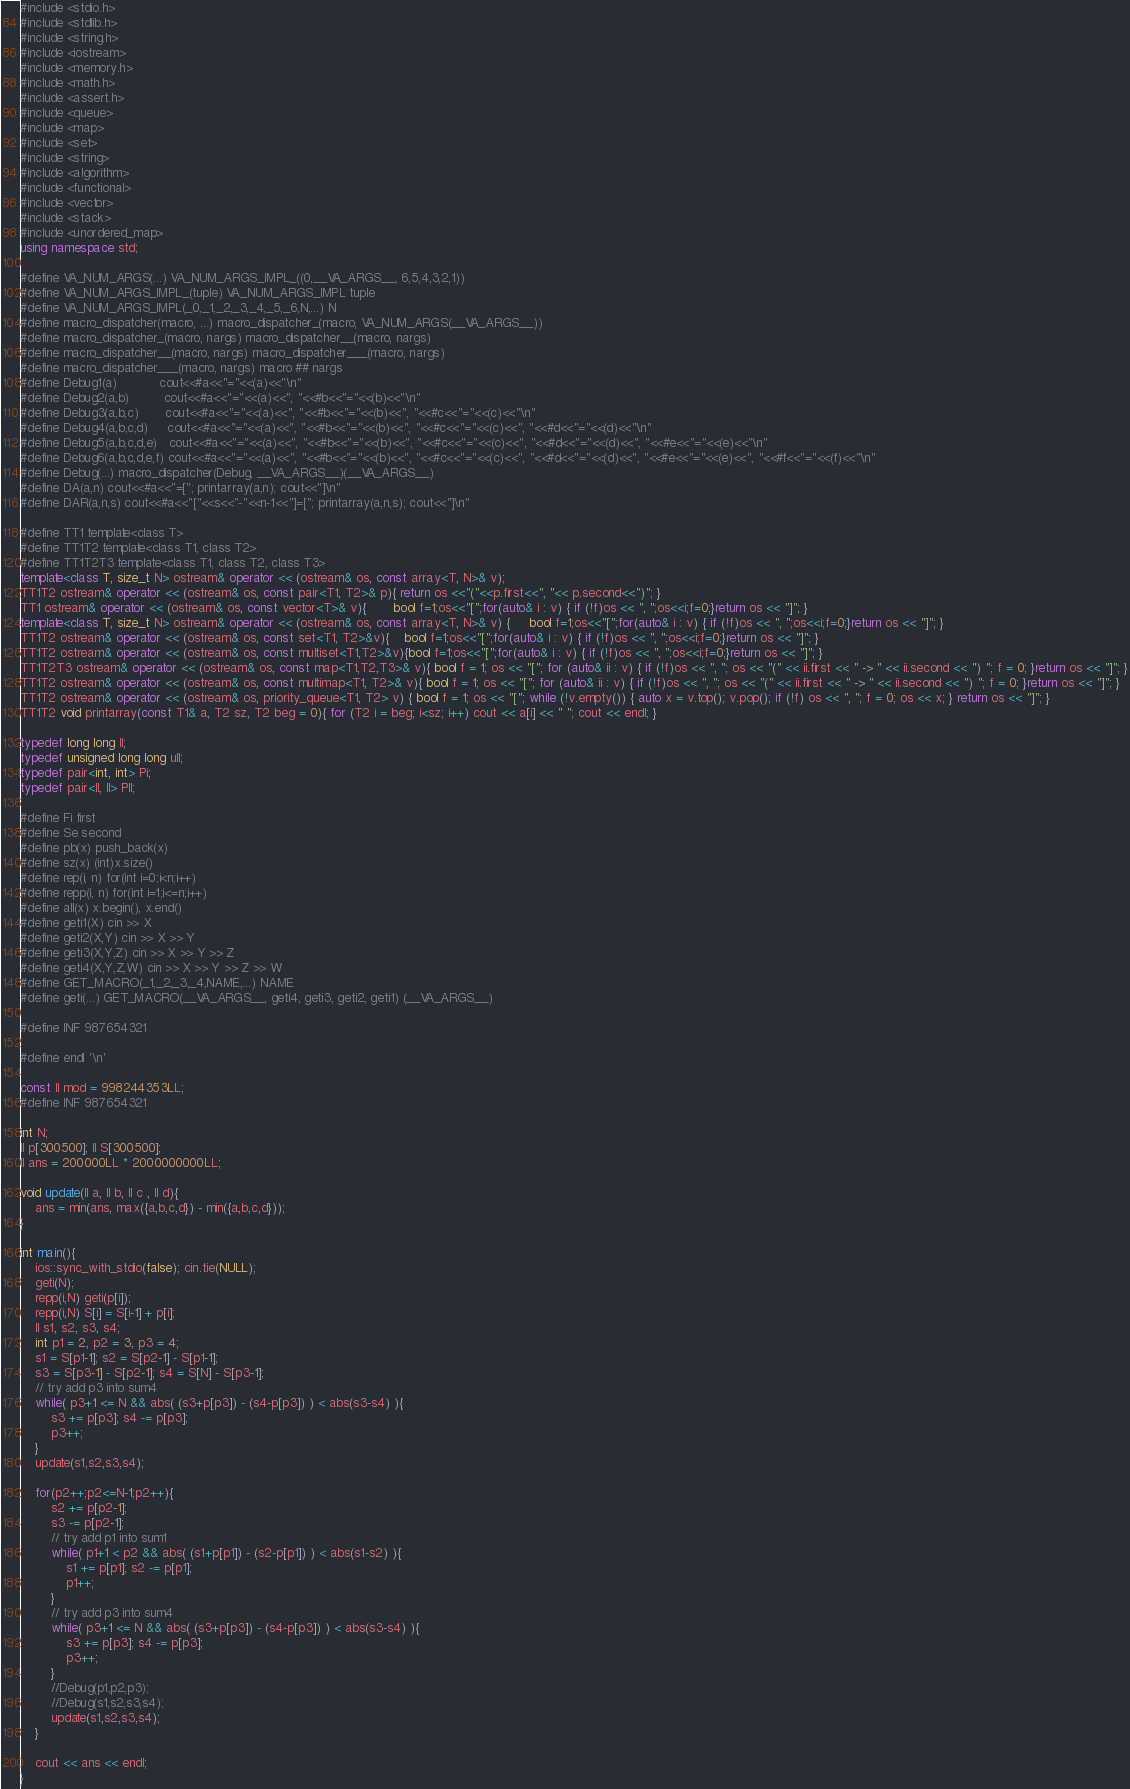<code> <loc_0><loc_0><loc_500><loc_500><_C++_>#include <stdio.h>
#include <stdlib.h>
#include <string.h>
#include <iostream>
#include <memory.h>
#include <math.h>
#include <assert.h>
#include <queue>
#include <map>
#include <set>
#include <string>
#include <algorithm>
#include <functional>
#include <vector>
#include <stack>
#include <unordered_map>
using namespace std;

#define VA_NUM_ARGS(...) VA_NUM_ARGS_IMPL_((0,__VA_ARGS__, 6,5,4,3,2,1))
#define VA_NUM_ARGS_IMPL_(tuple) VA_NUM_ARGS_IMPL tuple
#define VA_NUM_ARGS_IMPL(_0,_1,_2,_3,_4,_5,_6,N,...) N
#define macro_dispatcher(macro, ...) macro_dispatcher_(macro, VA_NUM_ARGS(__VA_ARGS__))
#define macro_dispatcher_(macro, nargs) macro_dispatcher__(macro, nargs)
#define macro_dispatcher__(macro, nargs) macro_dispatcher___(macro, nargs)
#define macro_dispatcher___(macro, nargs) macro ## nargs
#define Debug1(a)           cout<<#a<<"="<<(a)<<"\n"
#define Debug2(a,b)         cout<<#a<<"="<<(a)<<", "<<#b<<"="<<(b)<<"\n"
#define Debug3(a,b,c)       cout<<#a<<"="<<(a)<<", "<<#b<<"="<<(b)<<", "<<#c<<"="<<(c)<<"\n"
#define Debug4(a,b,c,d)     cout<<#a<<"="<<(a)<<", "<<#b<<"="<<(b)<<", "<<#c<<"="<<(c)<<", "<<#d<<"="<<(d)<<"\n"
#define Debug5(a,b,c,d,e)   cout<<#a<<"="<<(a)<<", "<<#b<<"="<<(b)<<", "<<#c<<"="<<(c)<<", "<<#d<<"="<<(d)<<", "<<#e<<"="<<(e)<<"\n"
#define Debug6(a,b,c,d,e,f) cout<<#a<<"="<<(a)<<", "<<#b<<"="<<(b)<<", "<<#c<<"="<<(c)<<", "<<#d<<"="<<(d)<<", "<<#e<<"="<<(e)<<", "<<#f<<"="<<(f)<<"\n"
#define Debug(...) macro_dispatcher(Debug, __VA_ARGS__)(__VA_ARGS__)
#define DA(a,n) cout<<#a<<"=["; printarray(a,n); cout<<"]\n"
#define DAR(a,n,s) cout<<#a<<"["<<s<<"-"<<n-1<<"]=["; printarray(a,n,s); cout<<"]\n"

#define TT1 template<class T>
#define TT1T2 template<class T1, class T2>
#define TT1T2T3 template<class T1, class T2, class T3>
template<class T, size_t N> ostream& operator << (ostream& os, const array<T, N>& v);
TT1T2 ostream& operator << (ostream& os, const pair<T1, T2>& p){ return os <<"("<<p.first<<", "<< p.second<<")"; }
TT1 ostream& operator << (ostream& os, const vector<T>& v){       bool f=1;os<<"[";for(auto& i : v) { if (!f)os << ", ";os<<i;f=0;}return os << "]"; }
template<class T, size_t N> ostream& operator << (ostream& os, const array<T, N>& v) {     bool f=1;os<<"[";for(auto& i : v) { if (!f)os << ", ";os<<i;f=0;}return os << "]"; }
TT1T2 ostream& operator << (ostream& os, const set<T1, T2>&v){    bool f=1;os<<"[";for(auto& i : v) { if (!f)os << ", ";os<<i;f=0;}return os << "]"; }
TT1T2 ostream& operator << (ostream& os, const multiset<T1,T2>&v){bool f=1;os<<"[";for(auto& i : v) { if (!f)os << ", ";os<<i;f=0;}return os << "]"; }
TT1T2T3 ostream& operator << (ostream& os, const map<T1,T2,T3>& v){ bool f = 1; os << "["; for (auto& ii : v) { if (!f)os << ", "; os << "(" << ii.first << " -> " << ii.second << ") "; f = 0; }return os << "]"; }
TT1T2 ostream& operator << (ostream& os, const multimap<T1, T2>& v){ bool f = 1; os << "["; for (auto& ii : v) { if (!f)os << ", "; os << "(" << ii.first << " -> " << ii.second << ") "; f = 0; }return os << "]"; }
TT1T2 ostream& operator << (ostream& os, priority_queue<T1, T2> v) { bool f = 1; os << "["; while (!v.empty()) { auto x = v.top(); v.pop(); if (!f) os << ", "; f = 0; os << x; } return os << "]"; }
TT1T2 void printarray(const T1& a, T2 sz, T2 beg = 0){ for (T2 i = beg; i<sz; i++) cout << a[i] << " "; cout << endl; }

typedef long long ll;
typedef unsigned long long ull;
typedef pair<int, int> Pi;
typedef pair<ll, ll> Pll;

#define Fi first
#define Se second
#define pb(x) push_back(x)
#define sz(x) (int)x.size()
#define rep(i, n) for(int i=0;i<n;i++)
#define repp(i, n) for(int i=1;i<=n;i++)
#define all(x) x.begin(), x.end()
#define geti1(X) cin >> X
#define geti2(X,Y) cin >> X >> Y
#define geti3(X,Y,Z) cin >> X >> Y >> Z
#define geti4(X,Y,Z,W) cin >> X >> Y >> Z >> W
#define GET_MACRO(_1,_2,_3,_4,NAME,...) NAME
#define geti(...) GET_MACRO(__VA_ARGS__, geti4, geti3, geti2, geti1) (__VA_ARGS__)

#define INF 987654321

#define endl '\n'

const ll mod = 998244353LL;
#define INF 987654321

int N;
ll p[300500]; ll S[300500];
ll ans = 200000LL * 2000000000LL;

void update(ll a, ll b, ll c , ll d){
	ans = min(ans, max({a,b,c,d}) - min({a,b,c,d}));
}

int main(){
	ios::sync_with_stdio(false); cin.tie(NULL);
	geti(N);
	repp(i,N) geti(p[i]);
	repp(i,N) S[i] = S[i-1] + p[i];
	ll s1, s2, s3, s4;
	int p1 = 2, p2 = 3, p3 = 4;
	s1 = S[p1-1]; s2 = S[p2-1] - S[p1-1];
	s3 = S[p3-1] - S[p2-1]; s4 = S[N] - S[p3-1];
	// try add p3 into sum4
	while( p3+1 <= N && abs( (s3+p[p3]) - (s4-p[p3]) ) < abs(s3-s4) ){
		s3 += p[p3]; s4 -= p[p3];
		p3++;
	}
	update(s1,s2,s3,s4);

	for(p2++;p2<=N-1;p2++){
		s2 += p[p2-1];
		s3 -= p[p2-1];
		// try add p1 into sum1
		while( p1+1 < p2 && abs( (s1+p[p1]) - (s2-p[p1]) ) < abs(s1-s2) ){
			s1 += p[p1]; s2 -= p[p1];
			p1++;
		}
		// try add p3 into sum4
		while( p3+1 <= N && abs( (s3+p[p3]) - (s4-p[p3]) ) < abs(s3-s4) ){
			s3 += p[p3]; s4 -= p[p3];
			p3++;
		}
		//Debug(p1,p2,p3);
		//Debug(s1,s2,s3,s4);
		update(s1,s2,s3,s4);
	}

	cout << ans << endl;
}








</code> 